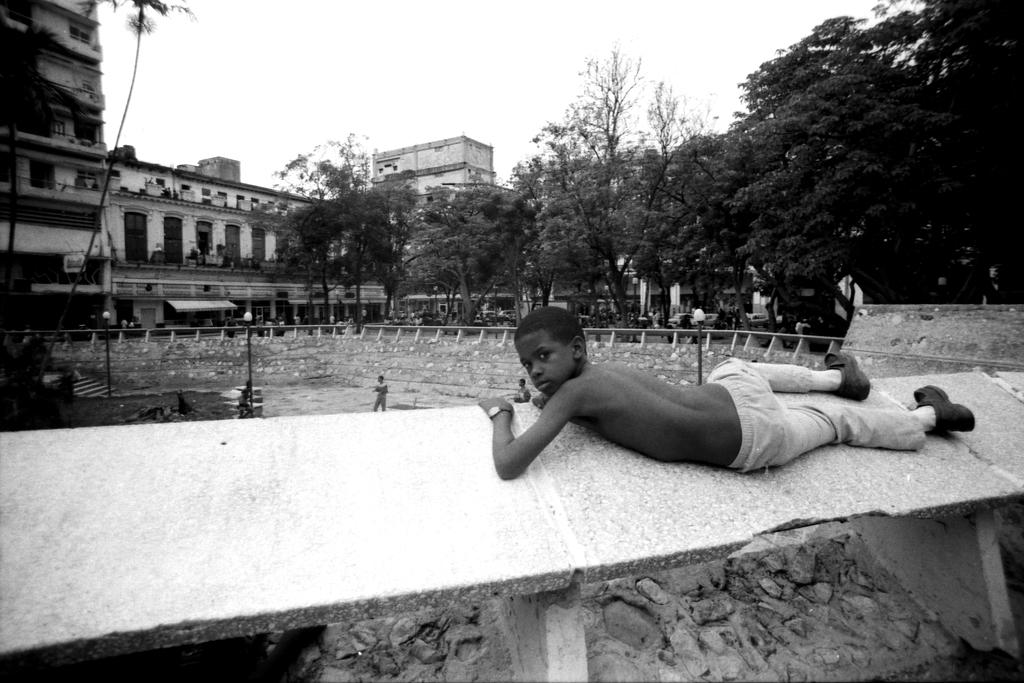What type of structures can be seen in the image? There are buildings in the image. What natural elements are present in the image? There are trees in the image. What type of lighting is present in the image? There are pole lights in the image. What are the boys in the image doing? There are boys on the ground in the image. Can you describe the position of one of the boys in the image? There is a boy lying on a wall in the image. What can be seen in the sky in the image? The sky is visible in the image. How many sheep are present in the image? There are no sheep present in the image. What is the amount of time it took for the boys to complete their journey in the image? There is no journey depicted in the image, so it is impossible to determine the amount of time it took for the boys to complete a journey. 